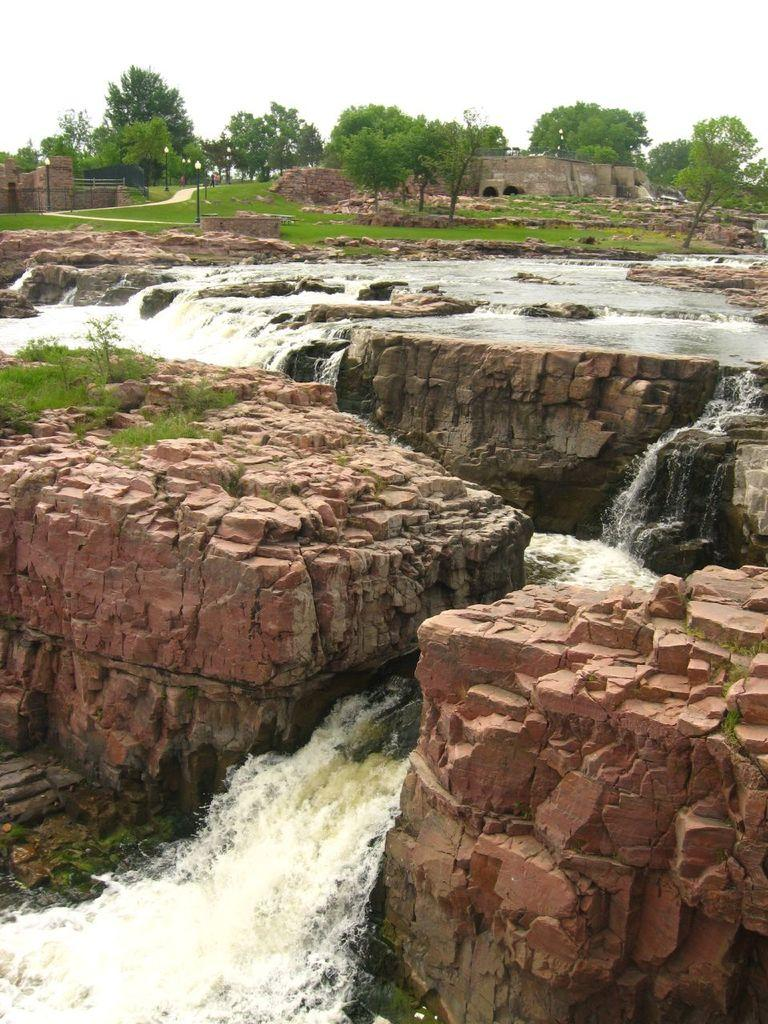What type of natural element is visible in the image? Floating water is visible in the image. What type of vegetation can be seen in the image? Grass, trees, and plants are visible in the image. What type of locket is hanging from the tree in the image? There is no locket present in the image; only grass, trees, and plants are visible. 